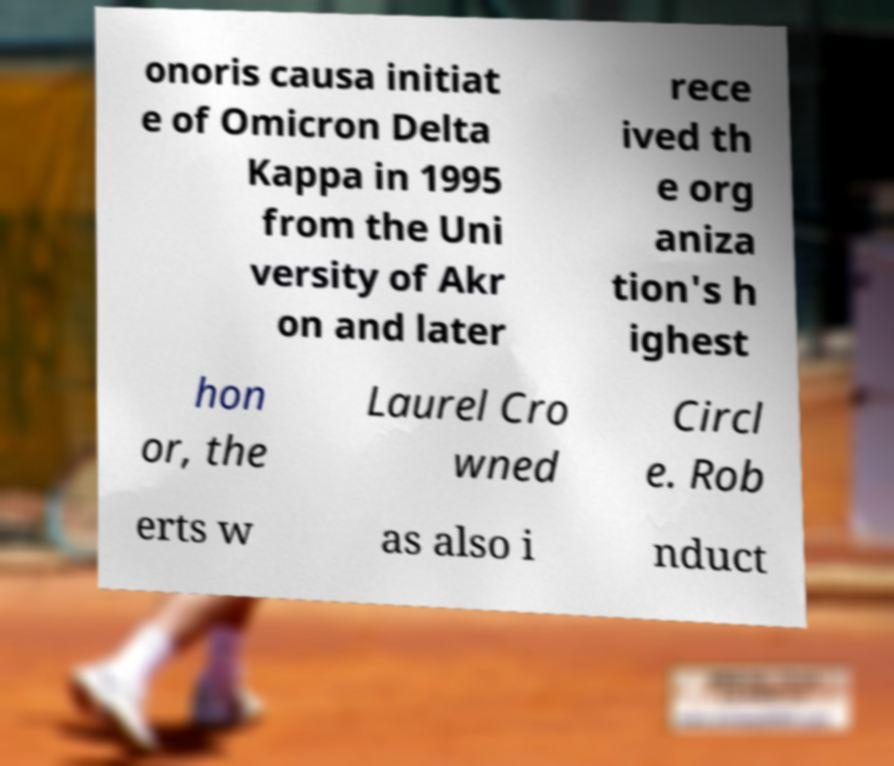There's text embedded in this image that I need extracted. Can you transcribe it verbatim? onoris causa initiat e of Omicron Delta Kappa in 1995 from the Uni versity of Akr on and later rece ived th e org aniza tion's h ighest hon or, the Laurel Cro wned Circl e. Rob erts w as also i nduct 